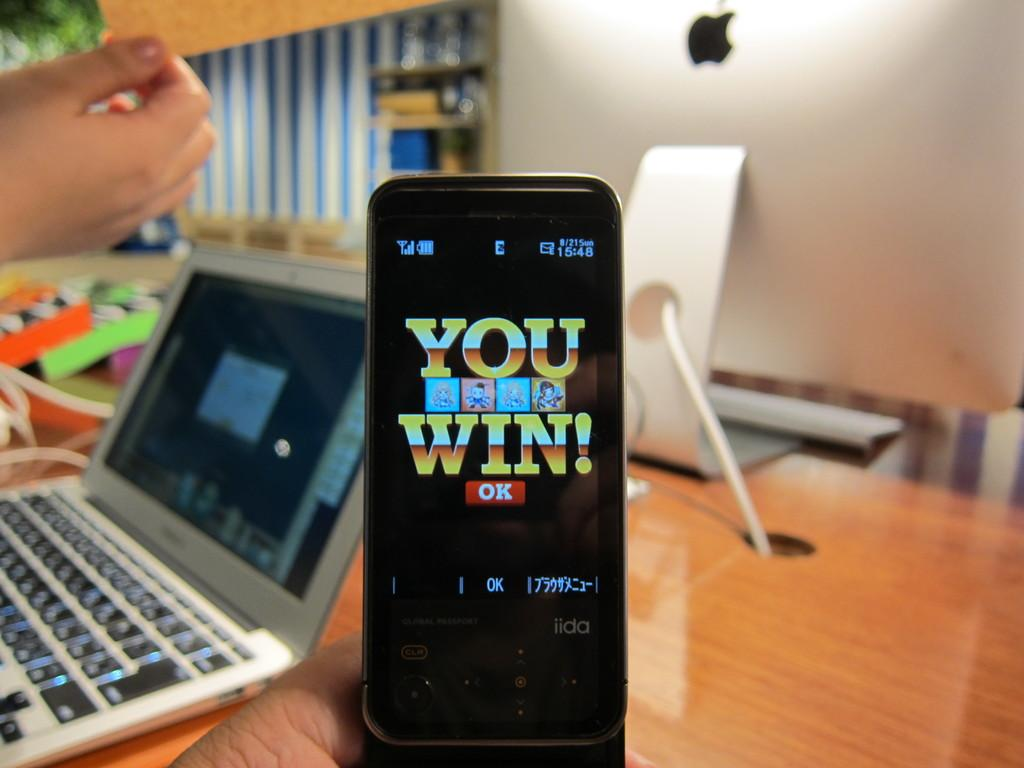<image>
Share a concise interpretation of the image provided. bright colored you win message on a phone next to an open laptop on a desk 